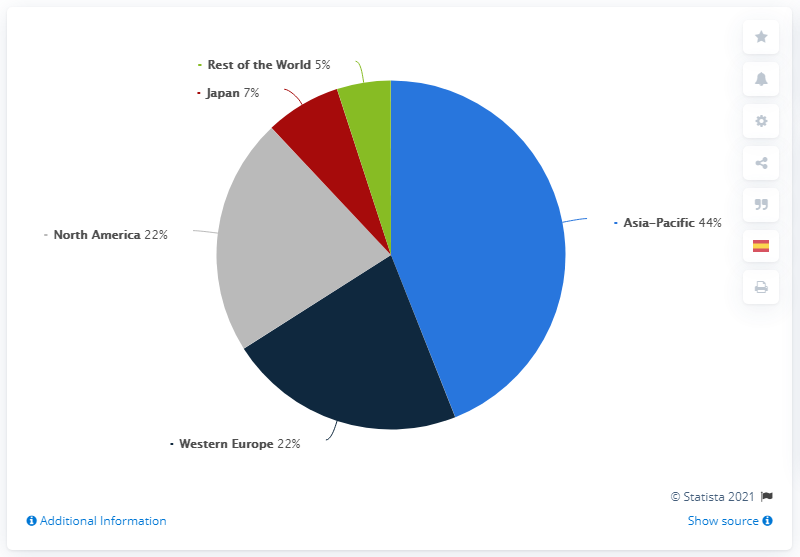Outline some significant characteristics in this image. In 2020, Gucci's global revenue for North America and Japan accounted for approximately 29% of the company's total revenue. According to the provided data, the Asia-Pacific region has the highest global revenue share of Gucci. 